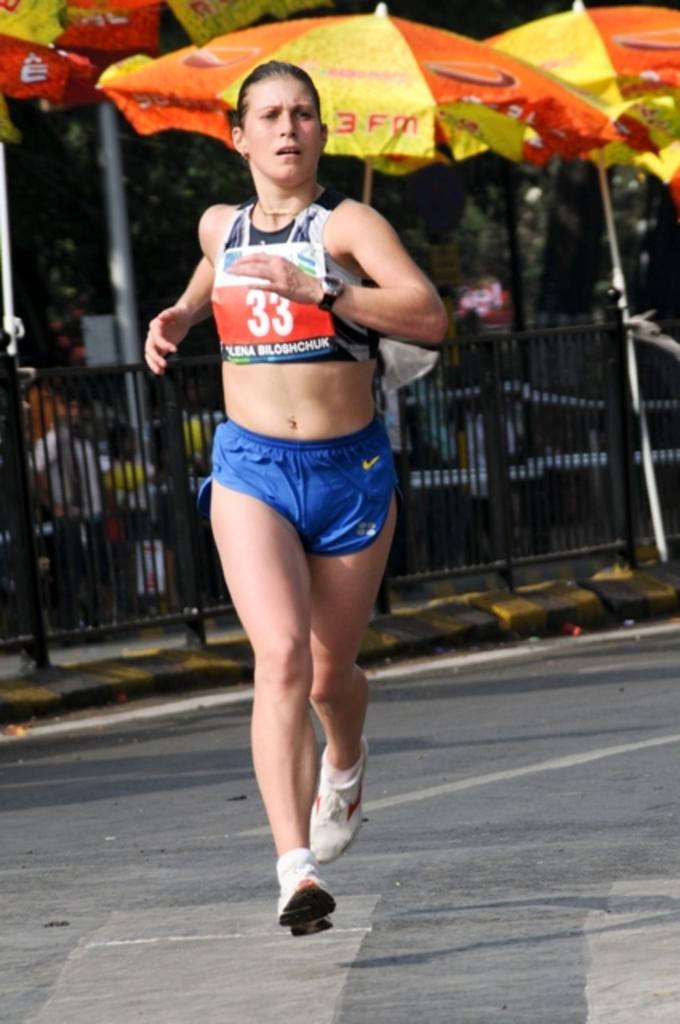What is the number printed on the shirt of this runner?
Give a very brief answer. 33. What color are the woman's shorts?
Offer a terse response. Answering does not require reading text in the image. 